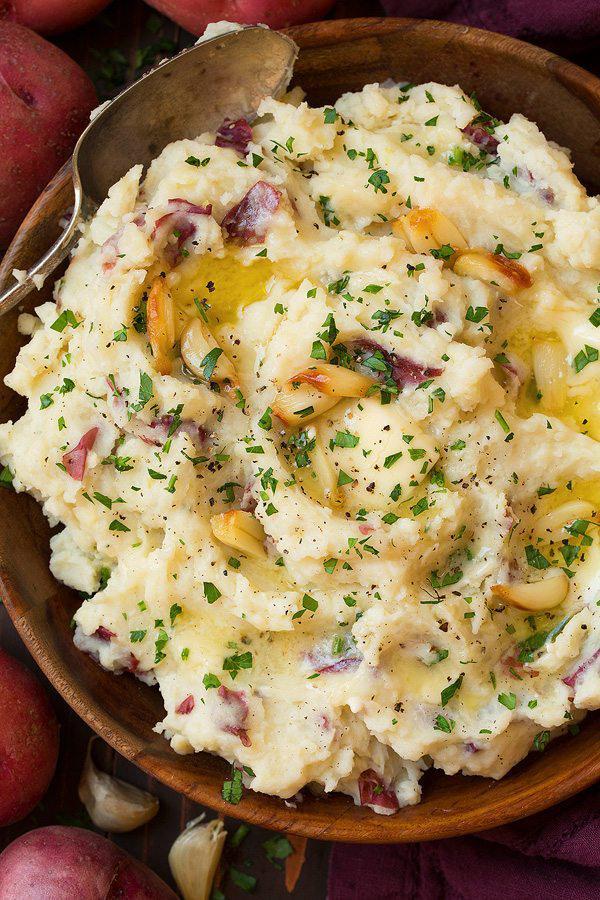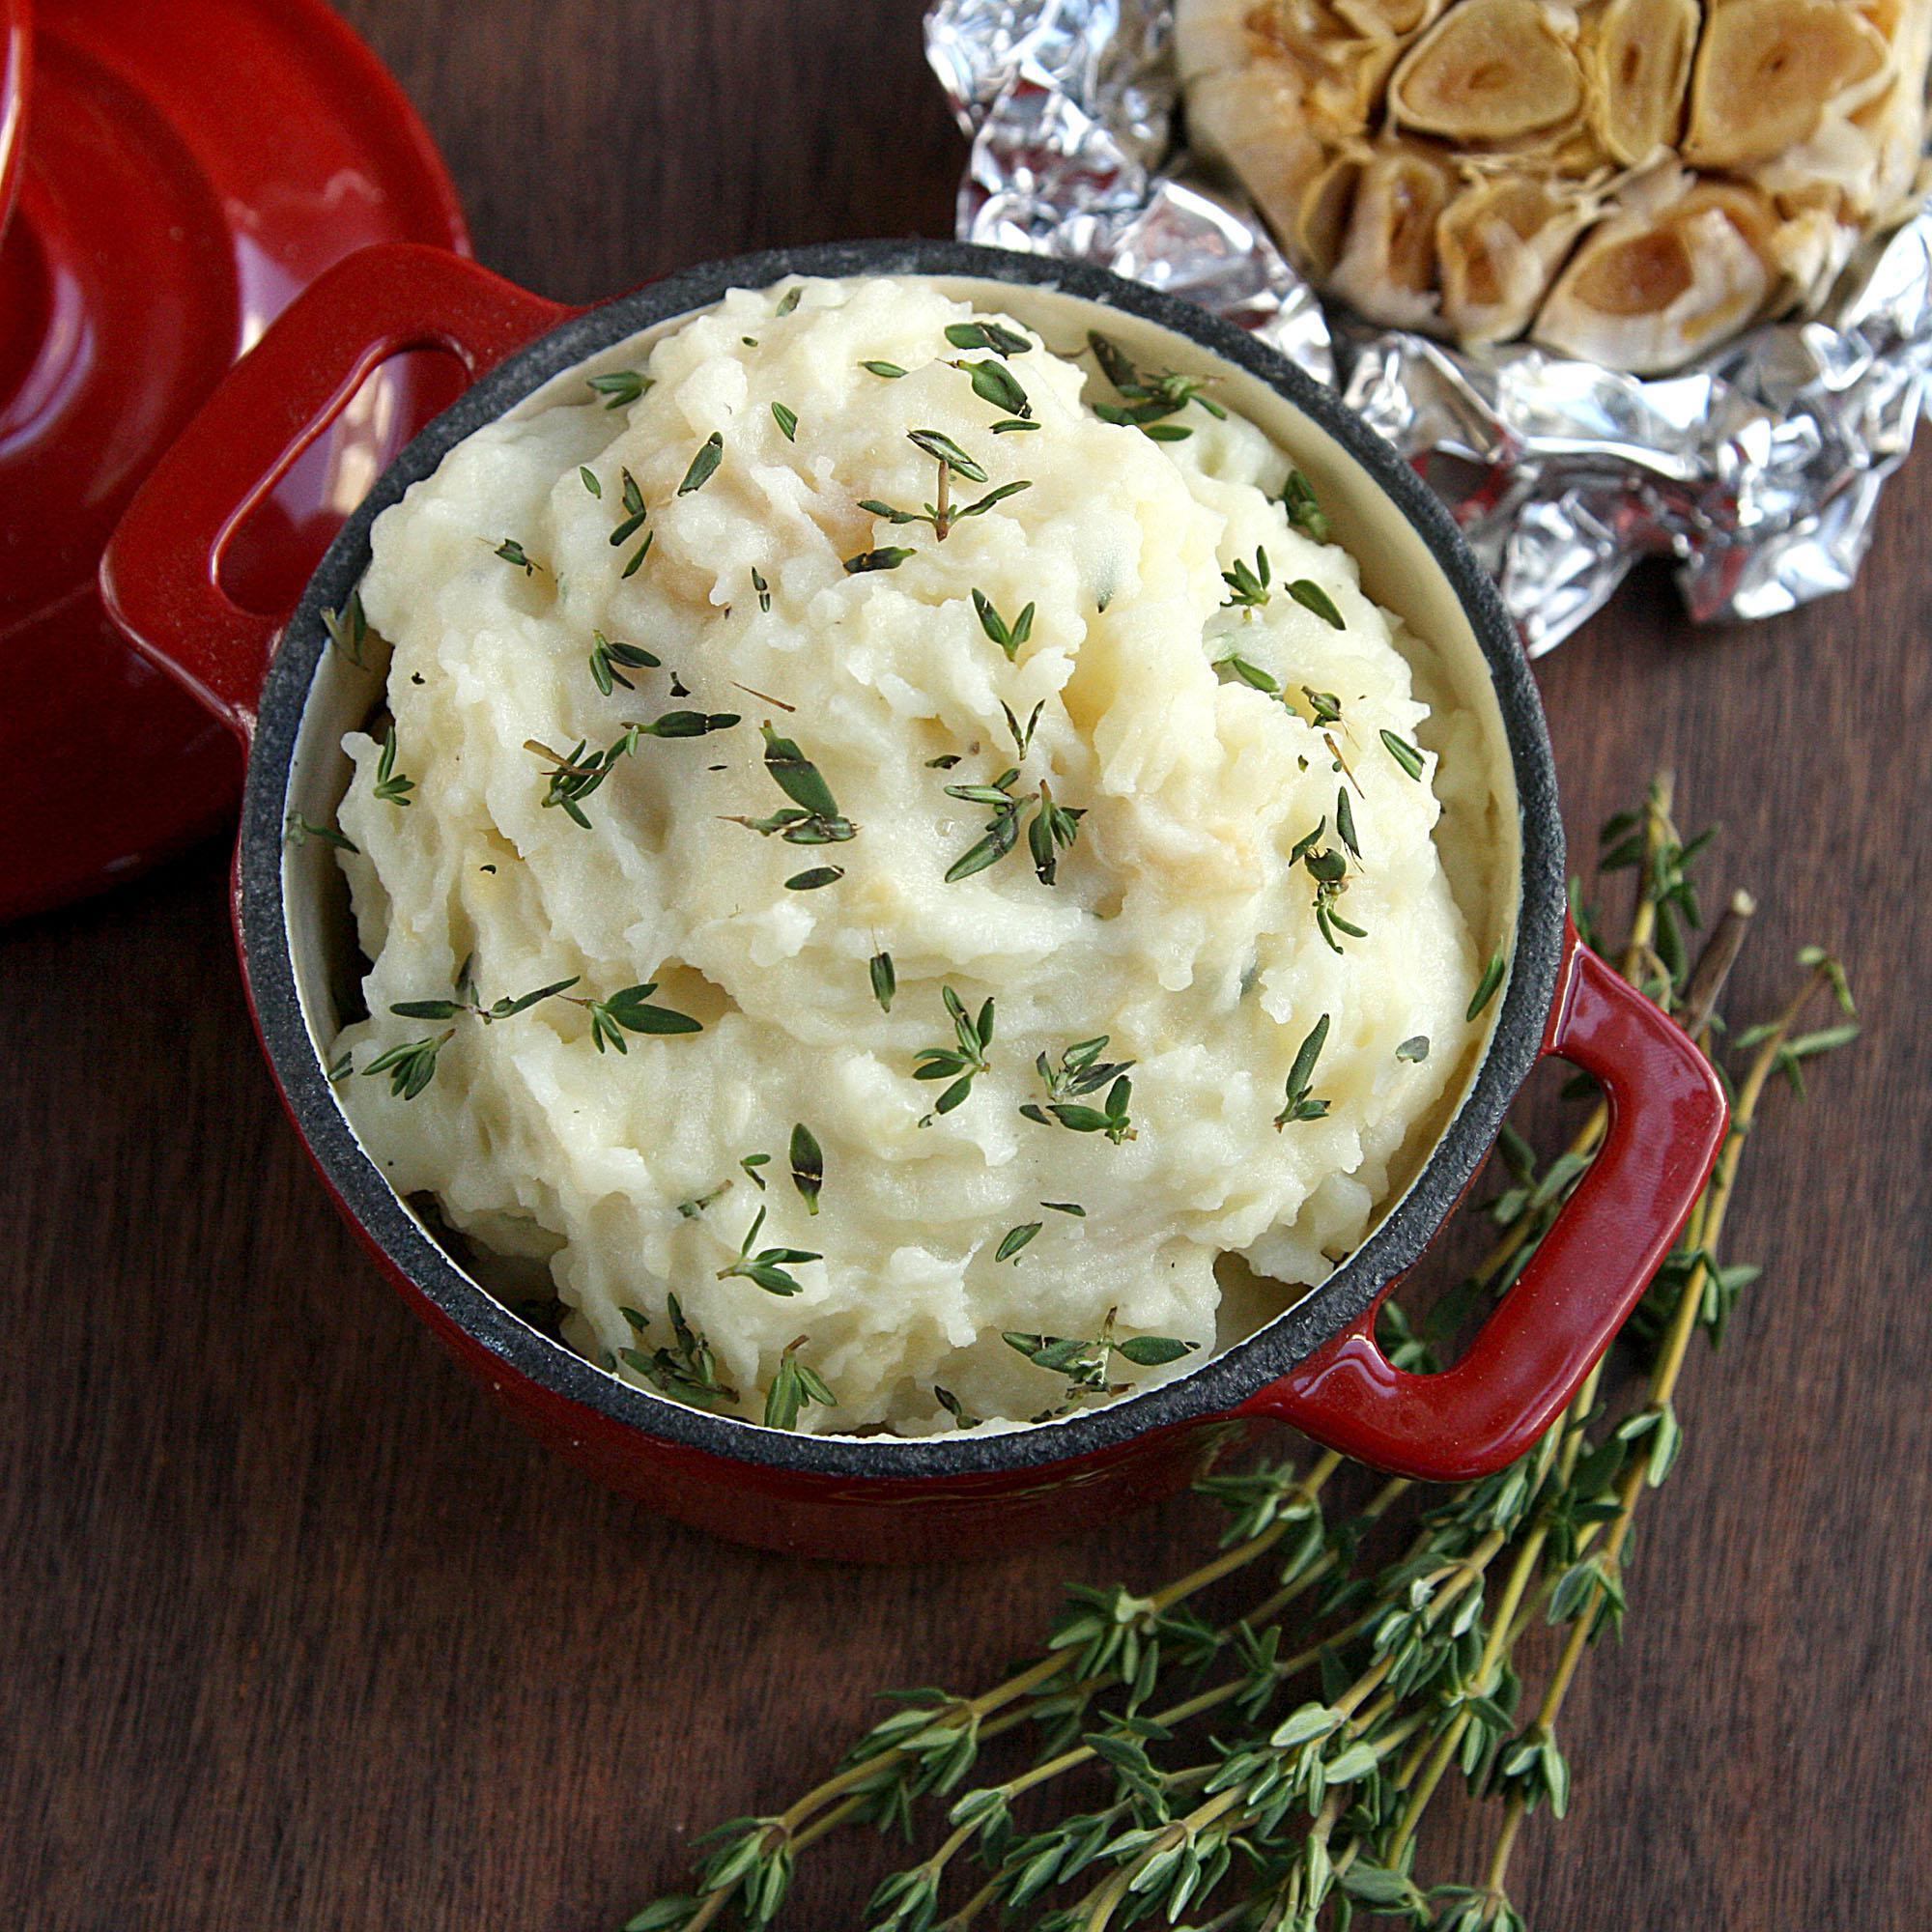The first image is the image on the left, the second image is the image on the right. Evaluate the accuracy of this statement regarding the images: "A cylindrical spice grinder is laying alongside a bowl of mashed potatoes doused with brownish liquid.". Is it true? Answer yes or no. No. The first image is the image on the left, the second image is the image on the right. Assess this claim about the two images: "There is a cylindrical, silver pepper grinder behind a bowl of mashed potatoes in one of the images.". Correct or not? Answer yes or no. No. 